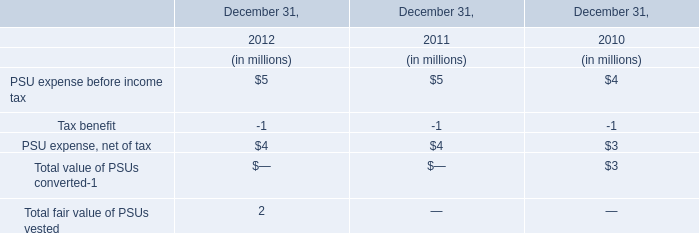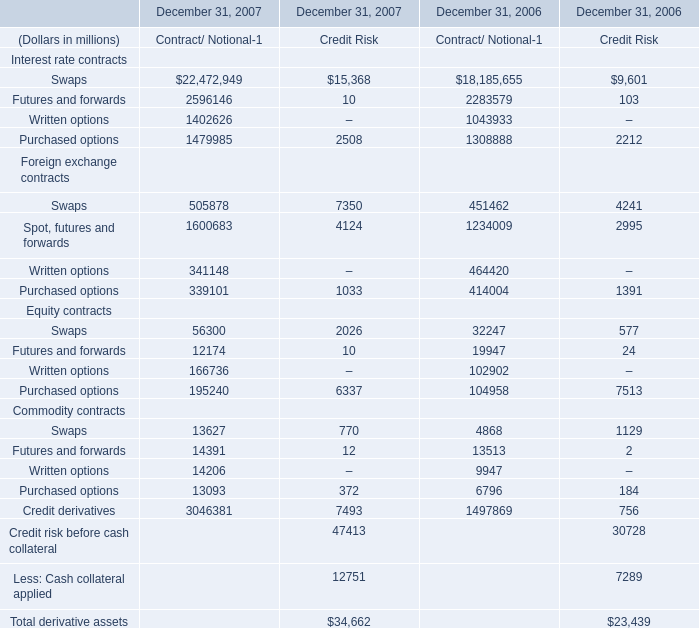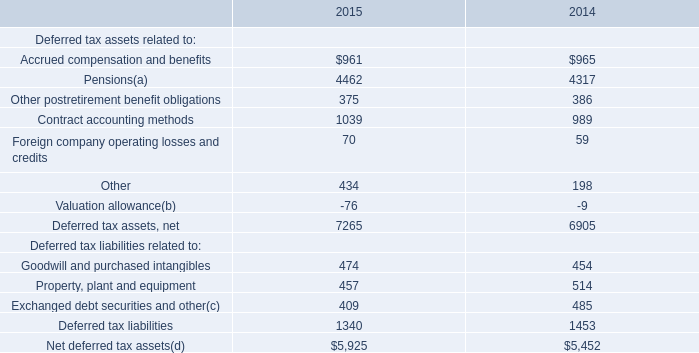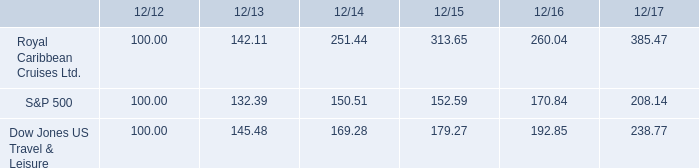What's the sum of Swaps Commodity contracts of December 31, 2006 Contract/ Notional, Contract accounting methods of 2015, and Written options of December 31, 2006 Contract/ Notional ? 
Computations: ((4868.0 + 1039.0) + 1043933.0)
Answer: 1049840.0. 